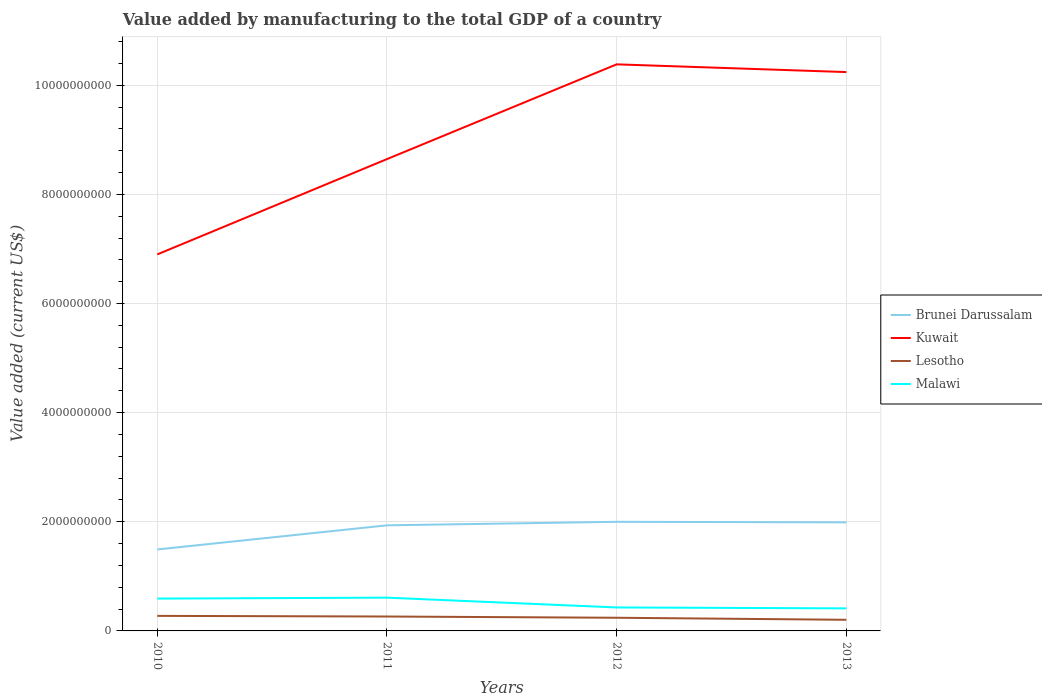Is the number of lines equal to the number of legend labels?
Provide a succinct answer. Yes. Across all years, what is the maximum value added by manufacturing to the total GDP in Kuwait?
Ensure brevity in your answer.  6.90e+09. In which year was the value added by manufacturing to the total GDP in Lesotho maximum?
Give a very brief answer. 2013. What is the total value added by manufacturing to the total GDP in Kuwait in the graph?
Give a very brief answer. -1.75e+09. What is the difference between the highest and the second highest value added by manufacturing to the total GDP in Lesotho?
Give a very brief answer. 7.15e+07. What is the difference between the highest and the lowest value added by manufacturing to the total GDP in Brunei Darussalam?
Provide a short and direct response. 3. Is the value added by manufacturing to the total GDP in Kuwait strictly greater than the value added by manufacturing to the total GDP in Brunei Darussalam over the years?
Offer a terse response. No. How many lines are there?
Keep it short and to the point. 4. How many years are there in the graph?
Ensure brevity in your answer.  4. Are the values on the major ticks of Y-axis written in scientific E-notation?
Your answer should be compact. No. Does the graph contain any zero values?
Offer a terse response. No. Where does the legend appear in the graph?
Make the answer very short. Center right. What is the title of the graph?
Your answer should be compact. Value added by manufacturing to the total GDP of a country. What is the label or title of the X-axis?
Your answer should be very brief. Years. What is the label or title of the Y-axis?
Offer a terse response. Value added (current US$). What is the Value added (current US$) of Brunei Darussalam in 2010?
Your response must be concise. 1.49e+09. What is the Value added (current US$) in Kuwait in 2010?
Offer a terse response. 6.90e+09. What is the Value added (current US$) in Lesotho in 2010?
Ensure brevity in your answer.  2.76e+08. What is the Value added (current US$) of Malawi in 2010?
Offer a very short reply. 5.92e+08. What is the Value added (current US$) of Brunei Darussalam in 2011?
Offer a terse response. 1.93e+09. What is the Value added (current US$) of Kuwait in 2011?
Offer a terse response. 8.65e+09. What is the Value added (current US$) in Lesotho in 2011?
Keep it short and to the point. 2.64e+08. What is the Value added (current US$) of Malawi in 2011?
Your answer should be very brief. 6.09e+08. What is the Value added (current US$) of Brunei Darussalam in 2012?
Provide a short and direct response. 2.00e+09. What is the Value added (current US$) of Kuwait in 2012?
Your response must be concise. 1.04e+1. What is the Value added (current US$) of Lesotho in 2012?
Make the answer very short. 2.41e+08. What is the Value added (current US$) of Malawi in 2012?
Your response must be concise. 4.30e+08. What is the Value added (current US$) of Brunei Darussalam in 2013?
Your response must be concise. 1.99e+09. What is the Value added (current US$) of Kuwait in 2013?
Your response must be concise. 1.02e+1. What is the Value added (current US$) in Lesotho in 2013?
Give a very brief answer. 2.04e+08. What is the Value added (current US$) in Malawi in 2013?
Make the answer very short. 4.13e+08. Across all years, what is the maximum Value added (current US$) in Brunei Darussalam?
Keep it short and to the point. 2.00e+09. Across all years, what is the maximum Value added (current US$) of Kuwait?
Provide a short and direct response. 1.04e+1. Across all years, what is the maximum Value added (current US$) of Lesotho?
Offer a terse response. 2.76e+08. Across all years, what is the maximum Value added (current US$) of Malawi?
Make the answer very short. 6.09e+08. Across all years, what is the minimum Value added (current US$) in Brunei Darussalam?
Make the answer very short. 1.49e+09. Across all years, what is the minimum Value added (current US$) of Kuwait?
Your response must be concise. 6.90e+09. Across all years, what is the minimum Value added (current US$) of Lesotho?
Provide a short and direct response. 2.04e+08. Across all years, what is the minimum Value added (current US$) in Malawi?
Provide a succinct answer. 4.13e+08. What is the total Value added (current US$) in Brunei Darussalam in the graph?
Keep it short and to the point. 7.42e+09. What is the total Value added (current US$) of Kuwait in the graph?
Your answer should be very brief. 3.62e+1. What is the total Value added (current US$) in Lesotho in the graph?
Your answer should be compact. 9.85e+08. What is the total Value added (current US$) of Malawi in the graph?
Offer a terse response. 2.05e+09. What is the difference between the Value added (current US$) of Brunei Darussalam in 2010 and that in 2011?
Make the answer very short. -4.42e+08. What is the difference between the Value added (current US$) in Kuwait in 2010 and that in 2011?
Ensure brevity in your answer.  -1.75e+09. What is the difference between the Value added (current US$) of Lesotho in 2010 and that in 2011?
Your answer should be compact. 1.19e+07. What is the difference between the Value added (current US$) of Malawi in 2010 and that in 2011?
Make the answer very short. -1.71e+07. What is the difference between the Value added (current US$) of Brunei Darussalam in 2010 and that in 2012?
Provide a succinct answer. -5.06e+08. What is the difference between the Value added (current US$) of Kuwait in 2010 and that in 2012?
Your answer should be very brief. -3.48e+09. What is the difference between the Value added (current US$) in Lesotho in 2010 and that in 2012?
Your answer should be very brief. 3.45e+07. What is the difference between the Value added (current US$) of Malawi in 2010 and that in 2012?
Your response must be concise. 1.62e+08. What is the difference between the Value added (current US$) of Brunei Darussalam in 2010 and that in 2013?
Offer a terse response. -4.97e+08. What is the difference between the Value added (current US$) of Kuwait in 2010 and that in 2013?
Provide a short and direct response. -3.34e+09. What is the difference between the Value added (current US$) of Lesotho in 2010 and that in 2013?
Keep it short and to the point. 7.15e+07. What is the difference between the Value added (current US$) of Malawi in 2010 and that in 2013?
Give a very brief answer. 1.79e+08. What is the difference between the Value added (current US$) in Brunei Darussalam in 2011 and that in 2012?
Provide a succinct answer. -6.45e+07. What is the difference between the Value added (current US$) of Kuwait in 2011 and that in 2012?
Provide a short and direct response. -1.74e+09. What is the difference between the Value added (current US$) in Lesotho in 2011 and that in 2012?
Ensure brevity in your answer.  2.26e+07. What is the difference between the Value added (current US$) in Malawi in 2011 and that in 2012?
Give a very brief answer. 1.79e+08. What is the difference between the Value added (current US$) of Brunei Darussalam in 2011 and that in 2013?
Give a very brief answer. -5.46e+07. What is the difference between the Value added (current US$) in Kuwait in 2011 and that in 2013?
Offer a terse response. -1.59e+09. What is the difference between the Value added (current US$) in Lesotho in 2011 and that in 2013?
Keep it short and to the point. 5.96e+07. What is the difference between the Value added (current US$) in Malawi in 2011 and that in 2013?
Provide a short and direct response. 1.96e+08. What is the difference between the Value added (current US$) in Brunei Darussalam in 2012 and that in 2013?
Offer a terse response. 9.83e+06. What is the difference between the Value added (current US$) in Kuwait in 2012 and that in 2013?
Offer a terse response. 1.42e+08. What is the difference between the Value added (current US$) of Lesotho in 2012 and that in 2013?
Keep it short and to the point. 3.70e+07. What is the difference between the Value added (current US$) of Malawi in 2012 and that in 2013?
Offer a terse response. 1.68e+07. What is the difference between the Value added (current US$) in Brunei Darussalam in 2010 and the Value added (current US$) in Kuwait in 2011?
Your answer should be very brief. -7.15e+09. What is the difference between the Value added (current US$) of Brunei Darussalam in 2010 and the Value added (current US$) of Lesotho in 2011?
Your response must be concise. 1.23e+09. What is the difference between the Value added (current US$) in Brunei Darussalam in 2010 and the Value added (current US$) in Malawi in 2011?
Your answer should be compact. 8.83e+08. What is the difference between the Value added (current US$) in Kuwait in 2010 and the Value added (current US$) in Lesotho in 2011?
Make the answer very short. 6.64e+09. What is the difference between the Value added (current US$) of Kuwait in 2010 and the Value added (current US$) of Malawi in 2011?
Provide a short and direct response. 6.29e+09. What is the difference between the Value added (current US$) in Lesotho in 2010 and the Value added (current US$) in Malawi in 2011?
Keep it short and to the point. -3.34e+08. What is the difference between the Value added (current US$) of Brunei Darussalam in 2010 and the Value added (current US$) of Kuwait in 2012?
Your answer should be very brief. -8.89e+09. What is the difference between the Value added (current US$) of Brunei Darussalam in 2010 and the Value added (current US$) of Lesotho in 2012?
Provide a succinct answer. 1.25e+09. What is the difference between the Value added (current US$) in Brunei Darussalam in 2010 and the Value added (current US$) in Malawi in 2012?
Offer a terse response. 1.06e+09. What is the difference between the Value added (current US$) in Kuwait in 2010 and the Value added (current US$) in Lesotho in 2012?
Make the answer very short. 6.66e+09. What is the difference between the Value added (current US$) of Kuwait in 2010 and the Value added (current US$) of Malawi in 2012?
Make the answer very short. 6.47e+09. What is the difference between the Value added (current US$) in Lesotho in 2010 and the Value added (current US$) in Malawi in 2012?
Offer a very short reply. -1.54e+08. What is the difference between the Value added (current US$) in Brunei Darussalam in 2010 and the Value added (current US$) in Kuwait in 2013?
Provide a short and direct response. -8.75e+09. What is the difference between the Value added (current US$) of Brunei Darussalam in 2010 and the Value added (current US$) of Lesotho in 2013?
Offer a very short reply. 1.29e+09. What is the difference between the Value added (current US$) in Brunei Darussalam in 2010 and the Value added (current US$) in Malawi in 2013?
Keep it short and to the point. 1.08e+09. What is the difference between the Value added (current US$) of Kuwait in 2010 and the Value added (current US$) of Lesotho in 2013?
Keep it short and to the point. 6.70e+09. What is the difference between the Value added (current US$) of Kuwait in 2010 and the Value added (current US$) of Malawi in 2013?
Offer a terse response. 6.49e+09. What is the difference between the Value added (current US$) in Lesotho in 2010 and the Value added (current US$) in Malawi in 2013?
Your response must be concise. -1.38e+08. What is the difference between the Value added (current US$) of Brunei Darussalam in 2011 and the Value added (current US$) of Kuwait in 2012?
Make the answer very short. -8.45e+09. What is the difference between the Value added (current US$) of Brunei Darussalam in 2011 and the Value added (current US$) of Lesotho in 2012?
Provide a succinct answer. 1.69e+09. What is the difference between the Value added (current US$) of Brunei Darussalam in 2011 and the Value added (current US$) of Malawi in 2012?
Provide a succinct answer. 1.50e+09. What is the difference between the Value added (current US$) of Kuwait in 2011 and the Value added (current US$) of Lesotho in 2012?
Keep it short and to the point. 8.40e+09. What is the difference between the Value added (current US$) of Kuwait in 2011 and the Value added (current US$) of Malawi in 2012?
Provide a short and direct response. 8.22e+09. What is the difference between the Value added (current US$) in Lesotho in 2011 and the Value added (current US$) in Malawi in 2012?
Provide a short and direct response. -1.66e+08. What is the difference between the Value added (current US$) in Brunei Darussalam in 2011 and the Value added (current US$) in Kuwait in 2013?
Your answer should be compact. -8.31e+09. What is the difference between the Value added (current US$) in Brunei Darussalam in 2011 and the Value added (current US$) in Lesotho in 2013?
Keep it short and to the point. 1.73e+09. What is the difference between the Value added (current US$) of Brunei Darussalam in 2011 and the Value added (current US$) of Malawi in 2013?
Keep it short and to the point. 1.52e+09. What is the difference between the Value added (current US$) of Kuwait in 2011 and the Value added (current US$) of Lesotho in 2013?
Offer a terse response. 8.44e+09. What is the difference between the Value added (current US$) in Kuwait in 2011 and the Value added (current US$) in Malawi in 2013?
Make the answer very short. 8.23e+09. What is the difference between the Value added (current US$) of Lesotho in 2011 and the Value added (current US$) of Malawi in 2013?
Your answer should be compact. -1.49e+08. What is the difference between the Value added (current US$) in Brunei Darussalam in 2012 and the Value added (current US$) in Kuwait in 2013?
Make the answer very short. -8.24e+09. What is the difference between the Value added (current US$) of Brunei Darussalam in 2012 and the Value added (current US$) of Lesotho in 2013?
Your answer should be very brief. 1.80e+09. What is the difference between the Value added (current US$) in Brunei Darussalam in 2012 and the Value added (current US$) in Malawi in 2013?
Ensure brevity in your answer.  1.59e+09. What is the difference between the Value added (current US$) of Kuwait in 2012 and the Value added (current US$) of Lesotho in 2013?
Give a very brief answer. 1.02e+1. What is the difference between the Value added (current US$) of Kuwait in 2012 and the Value added (current US$) of Malawi in 2013?
Make the answer very short. 9.97e+09. What is the difference between the Value added (current US$) in Lesotho in 2012 and the Value added (current US$) in Malawi in 2013?
Offer a terse response. -1.72e+08. What is the average Value added (current US$) of Brunei Darussalam per year?
Offer a terse response. 1.85e+09. What is the average Value added (current US$) of Kuwait per year?
Provide a short and direct response. 9.04e+09. What is the average Value added (current US$) of Lesotho per year?
Offer a terse response. 2.46e+08. What is the average Value added (current US$) of Malawi per year?
Offer a terse response. 5.11e+08. In the year 2010, what is the difference between the Value added (current US$) in Brunei Darussalam and Value added (current US$) in Kuwait?
Your answer should be compact. -5.41e+09. In the year 2010, what is the difference between the Value added (current US$) in Brunei Darussalam and Value added (current US$) in Lesotho?
Provide a succinct answer. 1.22e+09. In the year 2010, what is the difference between the Value added (current US$) in Brunei Darussalam and Value added (current US$) in Malawi?
Provide a short and direct response. 9.00e+08. In the year 2010, what is the difference between the Value added (current US$) of Kuwait and Value added (current US$) of Lesotho?
Keep it short and to the point. 6.62e+09. In the year 2010, what is the difference between the Value added (current US$) of Kuwait and Value added (current US$) of Malawi?
Provide a succinct answer. 6.31e+09. In the year 2010, what is the difference between the Value added (current US$) in Lesotho and Value added (current US$) in Malawi?
Give a very brief answer. -3.17e+08. In the year 2011, what is the difference between the Value added (current US$) in Brunei Darussalam and Value added (current US$) in Kuwait?
Offer a terse response. -6.71e+09. In the year 2011, what is the difference between the Value added (current US$) of Brunei Darussalam and Value added (current US$) of Lesotho?
Keep it short and to the point. 1.67e+09. In the year 2011, what is the difference between the Value added (current US$) in Brunei Darussalam and Value added (current US$) in Malawi?
Ensure brevity in your answer.  1.33e+09. In the year 2011, what is the difference between the Value added (current US$) of Kuwait and Value added (current US$) of Lesotho?
Offer a very short reply. 8.38e+09. In the year 2011, what is the difference between the Value added (current US$) in Kuwait and Value added (current US$) in Malawi?
Your answer should be compact. 8.04e+09. In the year 2011, what is the difference between the Value added (current US$) in Lesotho and Value added (current US$) in Malawi?
Offer a terse response. -3.46e+08. In the year 2012, what is the difference between the Value added (current US$) in Brunei Darussalam and Value added (current US$) in Kuwait?
Give a very brief answer. -8.38e+09. In the year 2012, what is the difference between the Value added (current US$) of Brunei Darussalam and Value added (current US$) of Lesotho?
Offer a terse response. 1.76e+09. In the year 2012, what is the difference between the Value added (current US$) of Brunei Darussalam and Value added (current US$) of Malawi?
Give a very brief answer. 1.57e+09. In the year 2012, what is the difference between the Value added (current US$) in Kuwait and Value added (current US$) in Lesotho?
Provide a succinct answer. 1.01e+1. In the year 2012, what is the difference between the Value added (current US$) of Kuwait and Value added (current US$) of Malawi?
Your answer should be compact. 9.95e+09. In the year 2012, what is the difference between the Value added (current US$) of Lesotho and Value added (current US$) of Malawi?
Provide a short and direct response. -1.89e+08. In the year 2013, what is the difference between the Value added (current US$) of Brunei Darussalam and Value added (current US$) of Kuwait?
Offer a terse response. -8.25e+09. In the year 2013, what is the difference between the Value added (current US$) of Brunei Darussalam and Value added (current US$) of Lesotho?
Provide a short and direct response. 1.79e+09. In the year 2013, what is the difference between the Value added (current US$) of Brunei Darussalam and Value added (current US$) of Malawi?
Give a very brief answer. 1.58e+09. In the year 2013, what is the difference between the Value added (current US$) in Kuwait and Value added (current US$) in Lesotho?
Your response must be concise. 1.00e+1. In the year 2013, what is the difference between the Value added (current US$) in Kuwait and Value added (current US$) in Malawi?
Ensure brevity in your answer.  9.83e+09. In the year 2013, what is the difference between the Value added (current US$) of Lesotho and Value added (current US$) of Malawi?
Make the answer very short. -2.09e+08. What is the ratio of the Value added (current US$) in Brunei Darussalam in 2010 to that in 2011?
Provide a short and direct response. 0.77. What is the ratio of the Value added (current US$) of Kuwait in 2010 to that in 2011?
Ensure brevity in your answer.  0.8. What is the ratio of the Value added (current US$) of Lesotho in 2010 to that in 2011?
Provide a succinct answer. 1.05. What is the ratio of the Value added (current US$) of Malawi in 2010 to that in 2011?
Make the answer very short. 0.97. What is the ratio of the Value added (current US$) of Brunei Darussalam in 2010 to that in 2012?
Offer a terse response. 0.75. What is the ratio of the Value added (current US$) in Kuwait in 2010 to that in 2012?
Provide a short and direct response. 0.66. What is the ratio of the Value added (current US$) of Lesotho in 2010 to that in 2012?
Provide a succinct answer. 1.14. What is the ratio of the Value added (current US$) in Malawi in 2010 to that in 2012?
Your answer should be very brief. 1.38. What is the ratio of the Value added (current US$) of Brunei Darussalam in 2010 to that in 2013?
Ensure brevity in your answer.  0.75. What is the ratio of the Value added (current US$) of Kuwait in 2010 to that in 2013?
Your response must be concise. 0.67. What is the ratio of the Value added (current US$) in Lesotho in 2010 to that in 2013?
Offer a terse response. 1.35. What is the ratio of the Value added (current US$) in Malawi in 2010 to that in 2013?
Your answer should be very brief. 1.43. What is the ratio of the Value added (current US$) of Brunei Darussalam in 2011 to that in 2012?
Provide a short and direct response. 0.97. What is the ratio of the Value added (current US$) in Kuwait in 2011 to that in 2012?
Provide a short and direct response. 0.83. What is the ratio of the Value added (current US$) in Lesotho in 2011 to that in 2012?
Provide a short and direct response. 1.09. What is the ratio of the Value added (current US$) in Malawi in 2011 to that in 2012?
Your response must be concise. 1.42. What is the ratio of the Value added (current US$) in Brunei Darussalam in 2011 to that in 2013?
Ensure brevity in your answer.  0.97. What is the ratio of the Value added (current US$) of Kuwait in 2011 to that in 2013?
Provide a succinct answer. 0.84. What is the ratio of the Value added (current US$) in Lesotho in 2011 to that in 2013?
Ensure brevity in your answer.  1.29. What is the ratio of the Value added (current US$) of Malawi in 2011 to that in 2013?
Your answer should be compact. 1.47. What is the ratio of the Value added (current US$) in Kuwait in 2012 to that in 2013?
Ensure brevity in your answer.  1.01. What is the ratio of the Value added (current US$) in Lesotho in 2012 to that in 2013?
Provide a succinct answer. 1.18. What is the ratio of the Value added (current US$) of Malawi in 2012 to that in 2013?
Offer a very short reply. 1.04. What is the difference between the highest and the second highest Value added (current US$) of Brunei Darussalam?
Your answer should be compact. 9.83e+06. What is the difference between the highest and the second highest Value added (current US$) in Kuwait?
Your response must be concise. 1.42e+08. What is the difference between the highest and the second highest Value added (current US$) in Lesotho?
Give a very brief answer. 1.19e+07. What is the difference between the highest and the second highest Value added (current US$) in Malawi?
Your answer should be very brief. 1.71e+07. What is the difference between the highest and the lowest Value added (current US$) of Brunei Darussalam?
Provide a short and direct response. 5.06e+08. What is the difference between the highest and the lowest Value added (current US$) of Kuwait?
Offer a terse response. 3.48e+09. What is the difference between the highest and the lowest Value added (current US$) of Lesotho?
Provide a short and direct response. 7.15e+07. What is the difference between the highest and the lowest Value added (current US$) in Malawi?
Provide a short and direct response. 1.96e+08. 